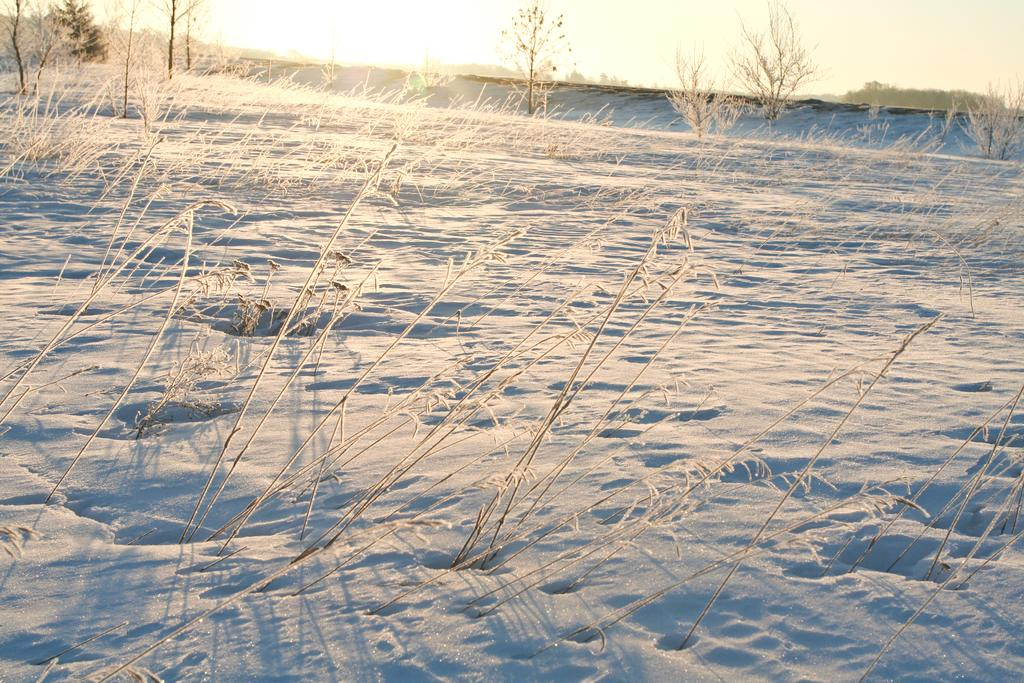What is located at the bottom of the picture? There are plants and ice at the bottom of the picture. What can be seen in the background of the picture? There are trees in the background of the picture. What is visible at the top of the picture? The sun is visible at the top of the picture. What can be inferred about the weather based on the presence of the sun? It is a sunny day. What is the purpose of the smile in the image? There is no smile present in the image, as it features plants, ice, trees, and the sun. What color is the sky in the image? The provided facts do not mention the color of the sky, only that the sun is visible at the top of the picture. 